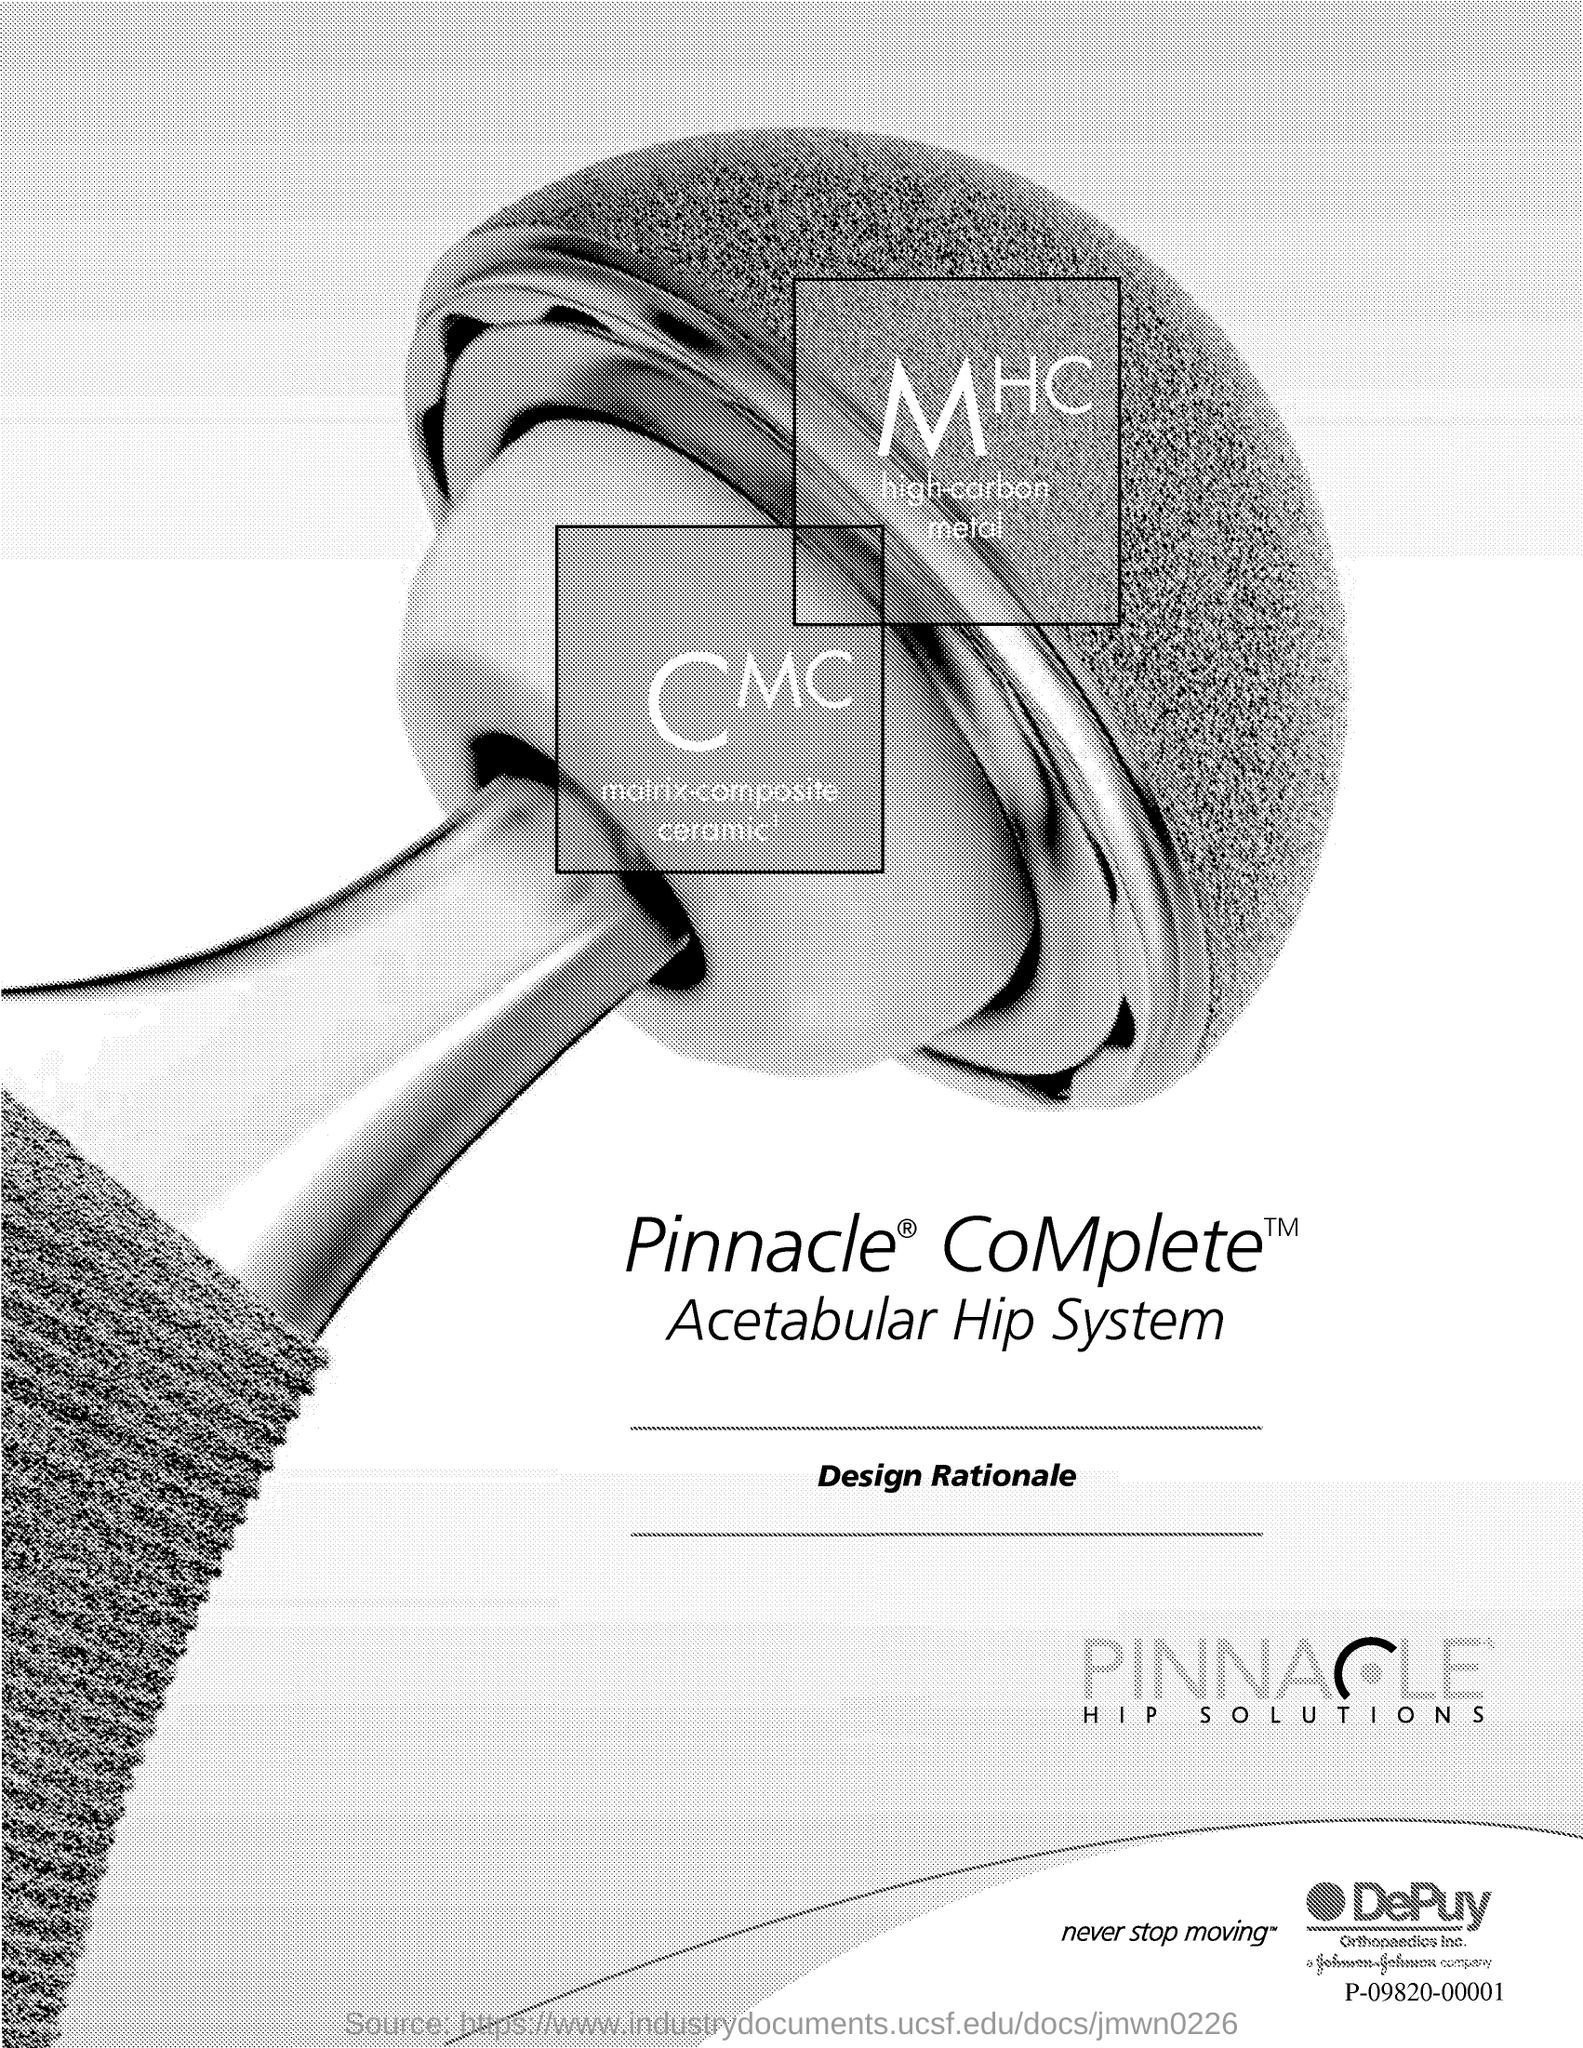What is the title that is written in-between two lines?
Your answer should be very brief. Design Rationale. 